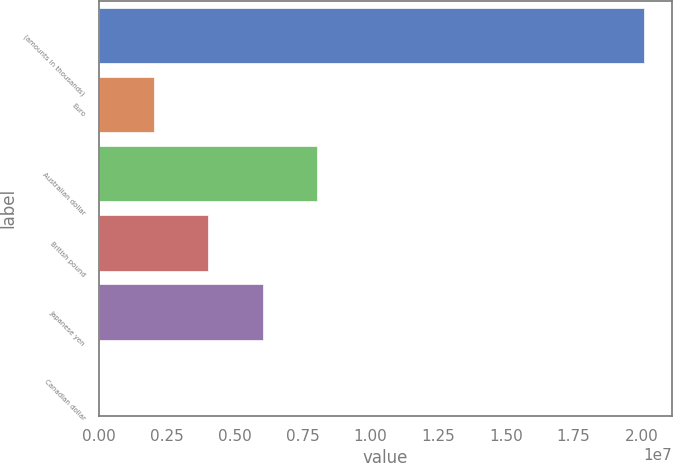Convert chart to OTSL. <chart><loc_0><loc_0><loc_500><loc_500><bar_chart><fcel>(amounts in thousands)<fcel>Euro<fcel>Australian dollar<fcel>British pound<fcel>Japanese yen<fcel>Canadian dollar<nl><fcel>2.0112e+07<fcel>2.0112e+06<fcel>8.0448e+06<fcel>4.0224e+06<fcel>6.0336e+06<fcel>1<nl></chart> 